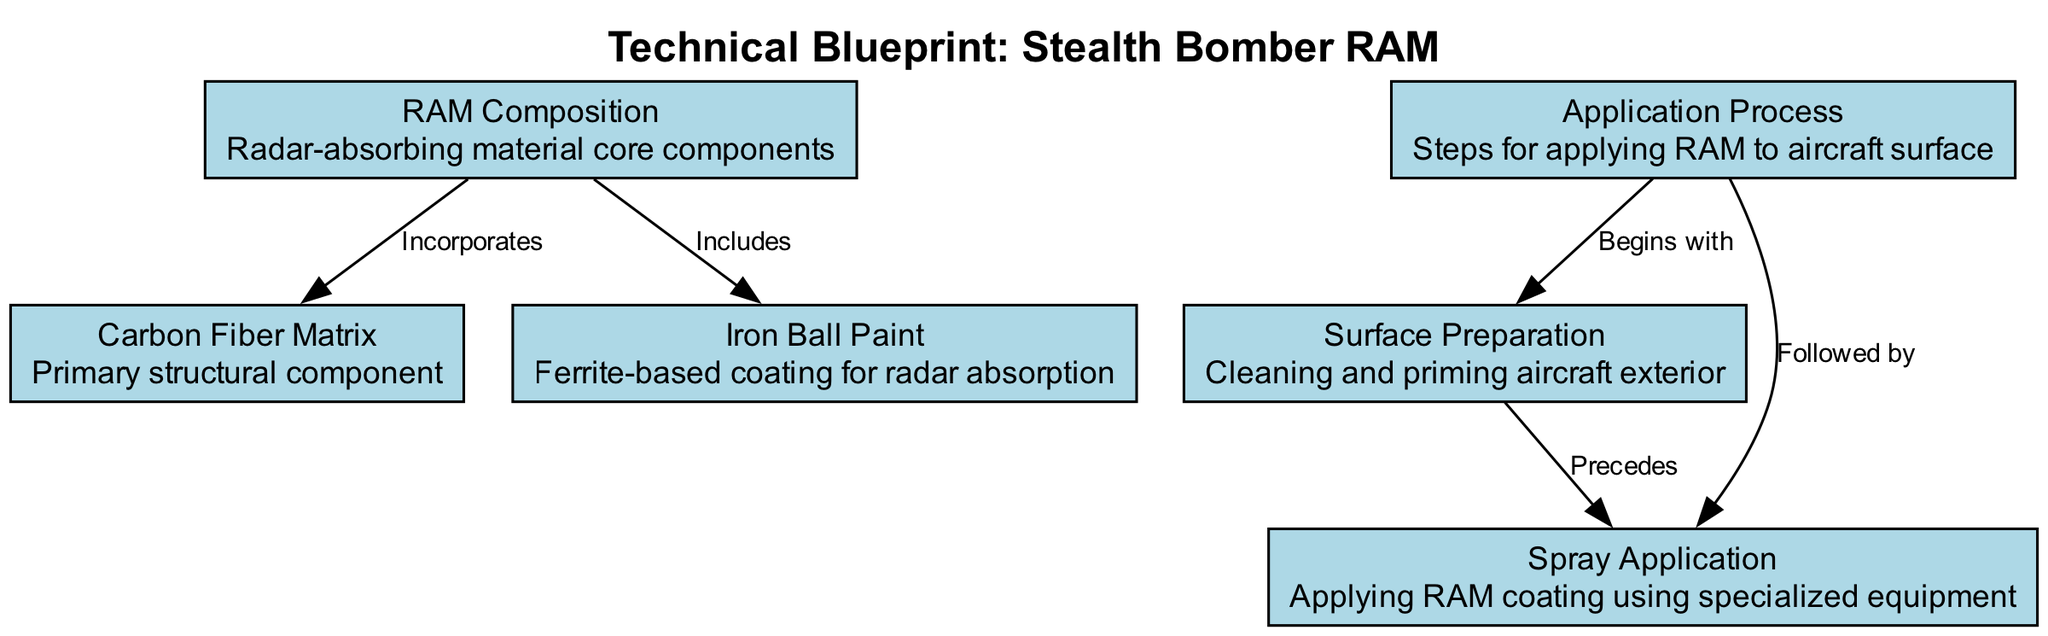What are the core components of RAM? The node labeled "RAM Composition" lists "RAM Composition" as its name and describes it as "Radar-absorbing material core components." This directly indicates the nature of the components, which is essential.
Answer: Radar-absorbing material core components What is the primary structural component of the RAM? The node identified as "Carbon Fiber Matrix" states that it is the "Primary structural component." This is a straightforward identification from the node.
Answer: Carbon Fiber Matrix How many total nodes are present in the diagram? By counting each node listed in the "nodes" section of the data, there are 6 distinct nodes specified. Thus, the overall number can be calculated by direct enumeration.
Answer: 6 What is the first step in the application process? According to the "Application Process" node, it begins with "Surface Preparation," which is denoted as the first step connecting to the following steps in the process.
Answer: Surface Preparation What does the "Iron Ball Paint" node include? The edges from "RAM Composition" to "Iron Ball Paint" indicate it includes "Ferrite-based coating for radar absorption," directly tying the description to its node through the connecting edge.
Answer: Ferrite-based coating for radar absorption What step follows after applying surface preparation? Following the "Surface Preparation" node as indicated by the edge "Precedes," the next step in the application process is "Spray Application," which directly connects to the procedures involved.
Answer: Spray Application What function does the Carbon Fiber Matrix have in relation to RAM? The edge labeled "Incorporates" between the nodes "RAM Composition" and "Carbon Fiber Matrix" clearly shows that the Carbon Fiber Matrix is a part of or incorporated into the RAM.
Answer: Incorporates What is the connection between the Application Process and Spray Application? The connection is made through the label "Followed by" on the edge leading from the "Application Process" node to the "Spray Application" node, indicating sequential steps in the procedure.
Answer: Followed by 